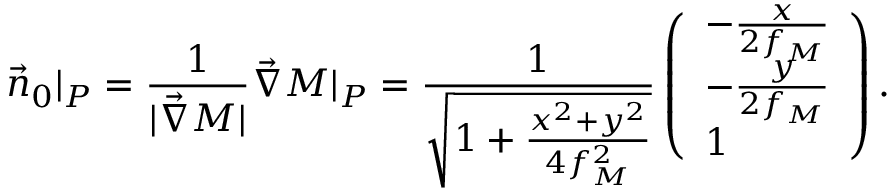<formula> <loc_0><loc_0><loc_500><loc_500>\vec { n } _ { 0 } | _ { P } = \frac { 1 } { | \vec { \nabla } M | } \vec { \nabla } M | _ { P } = \frac { 1 } { \sqrt { 1 + \frac { x ^ { 2 } + y ^ { 2 } } { 4 f _ { M } ^ { 2 } } } } \left ( \begin{array} { l } { - \frac { x } { 2 f _ { M } } } \\ { - \frac { y } { 2 f _ { M } } } \\ { 1 } \end{array} \right ) .</formula> 